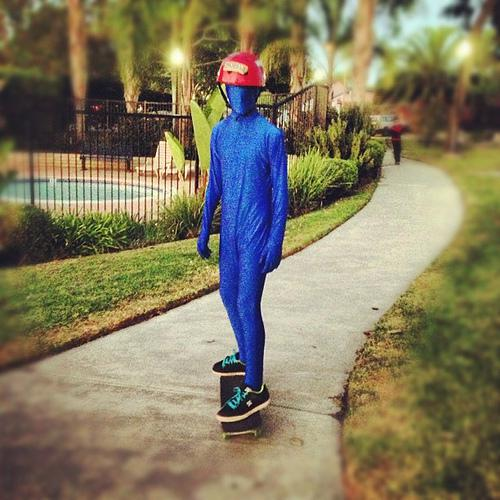Question: who is in the foreground of this picture?
Choices:
A. The athlete.
B. The performer.
C. The man.
D. A skateboarder.
Answer with the letter. Answer: D Question: where is the skateboard?
Choices:
A. Under the skateboarder.
B. On the road.
C. In the guy's hand.
D. In the closet.
Answer with the letter. Answer: A Question: what color are the skateboarder's shoelaces?
Choices:
A. Black.
B. Green.
C. Blue.
D. White.
Answer with the letter. Answer: C Question: how many people are in this picture?
Choices:
A. Two.
B. One.
C. Zero.
D. Three.
Answer with the letter. Answer: A Question: what is on the skateboarder's head?
Choices:
A. A hat.
B. A bandana.
C. A helmet.
D. Hair.
Answer with the letter. Answer: C 